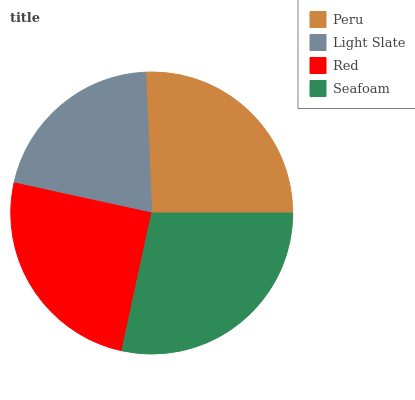Is Light Slate the minimum?
Answer yes or no. Yes. Is Seafoam the maximum?
Answer yes or no. Yes. Is Red the minimum?
Answer yes or no. No. Is Red the maximum?
Answer yes or no. No. Is Red greater than Light Slate?
Answer yes or no. Yes. Is Light Slate less than Red?
Answer yes or no. Yes. Is Light Slate greater than Red?
Answer yes or no. No. Is Red less than Light Slate?
Answer yes or no. No. Is Peru the high median?
Answer yes or no. Yes. Is Red the low median?
Answer yes or no. Yes. Is Red the high median?
Answer yes or no. No. Is Seafoam the low median?
Answer yes or no. No. 